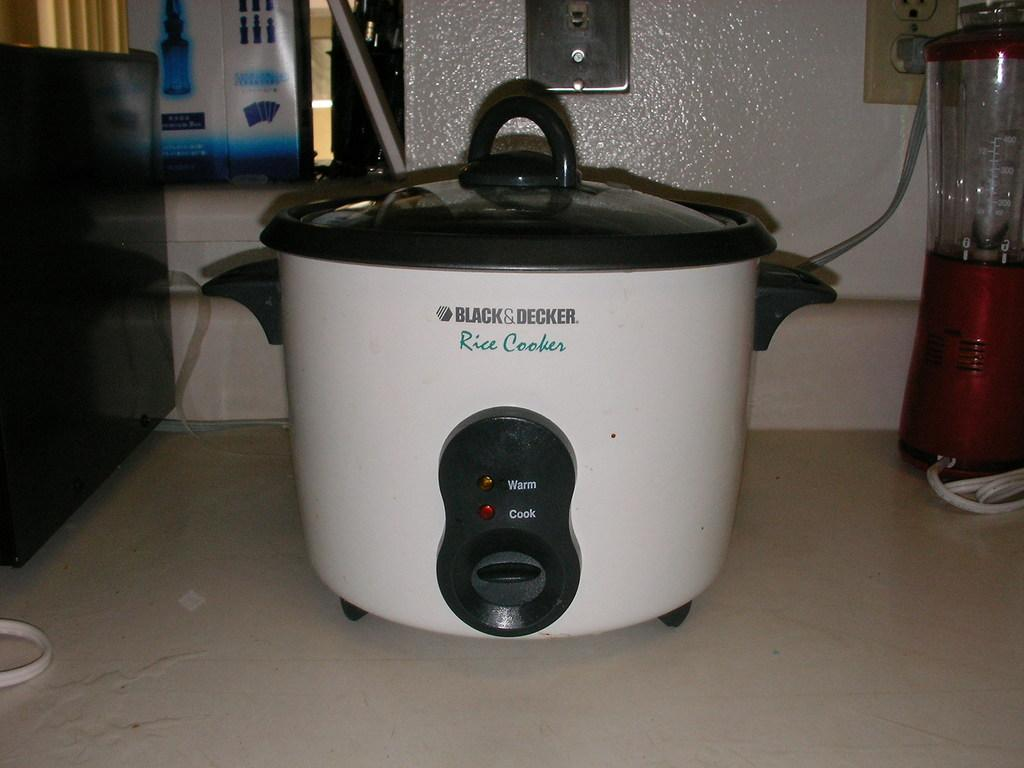<image>
Offer a succinct explanation of the picture presented. A Black & Decker rice cooker pot sitting on a white counter top. 